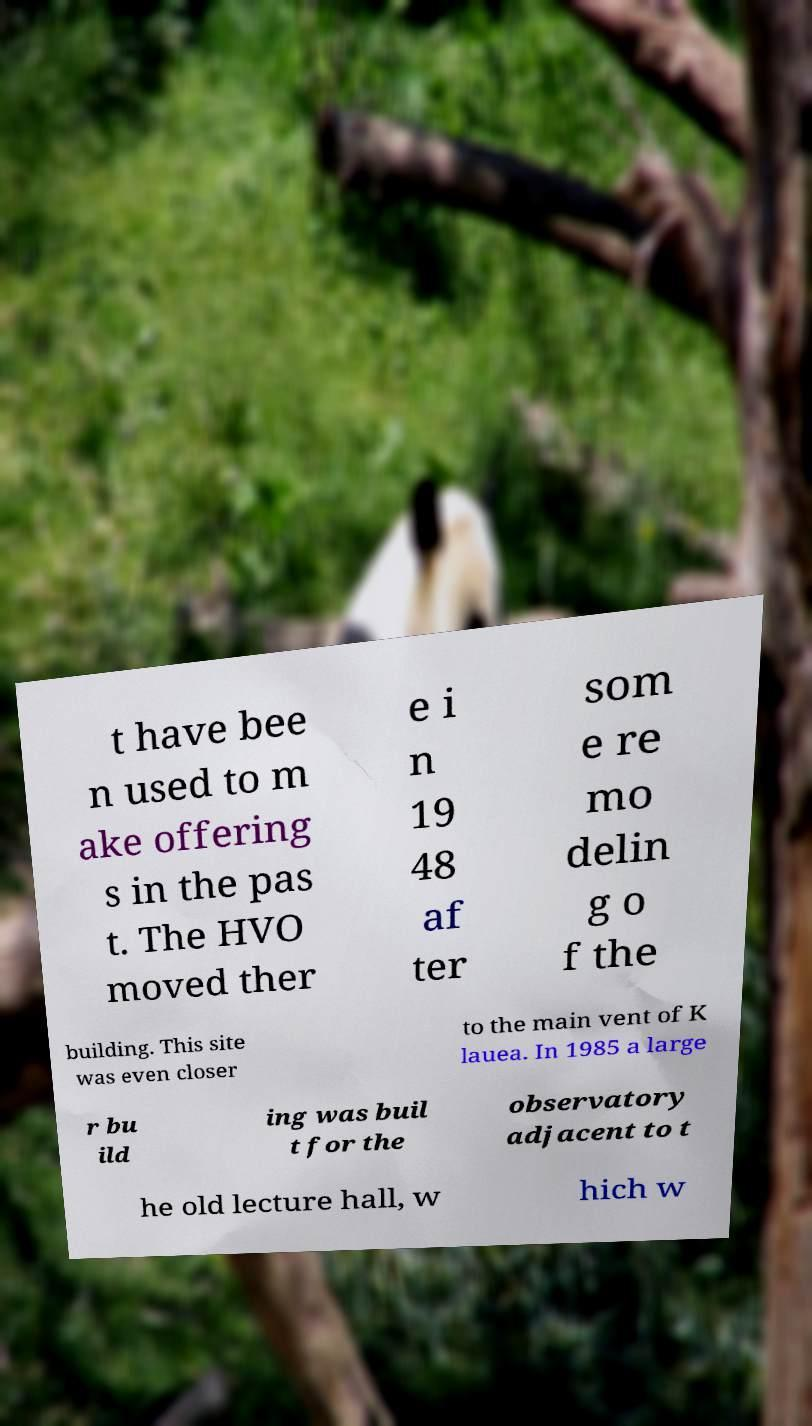For documentation purposes, I need the text within this image transcribed. Could you provide that? t have bee n used to m ake offering s in the pas t. The HVO moved ther e i n 19 48 af ter som e re mo delin g o f the building. This site was even closer to the main vent of K lauea. In 1985 a large r bu ild ing was buil t for the observatory adjacent to t he old lecture hall, w hich w 